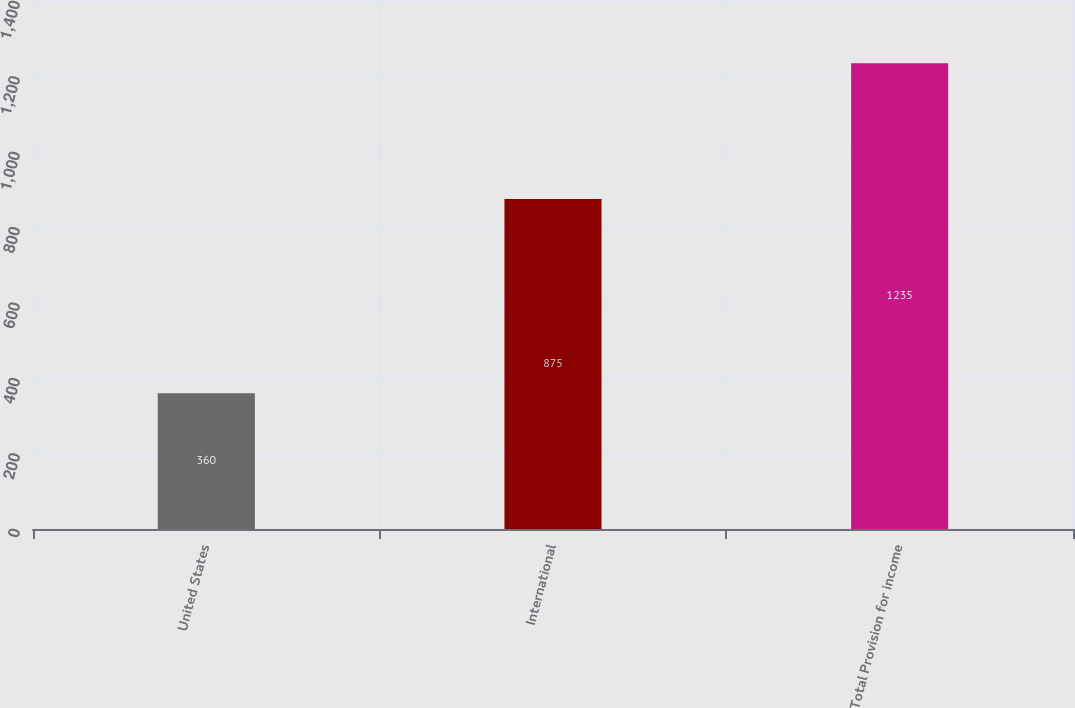Convert chart to OTSL. <chart><loc_0><loc_0><loc_500><loc_500><bar_chart><fcel>United States<fcel>International<fcel>Total Provision for income<nl><fcel>360<fcel>875<fcel>1235<nl></chart> 